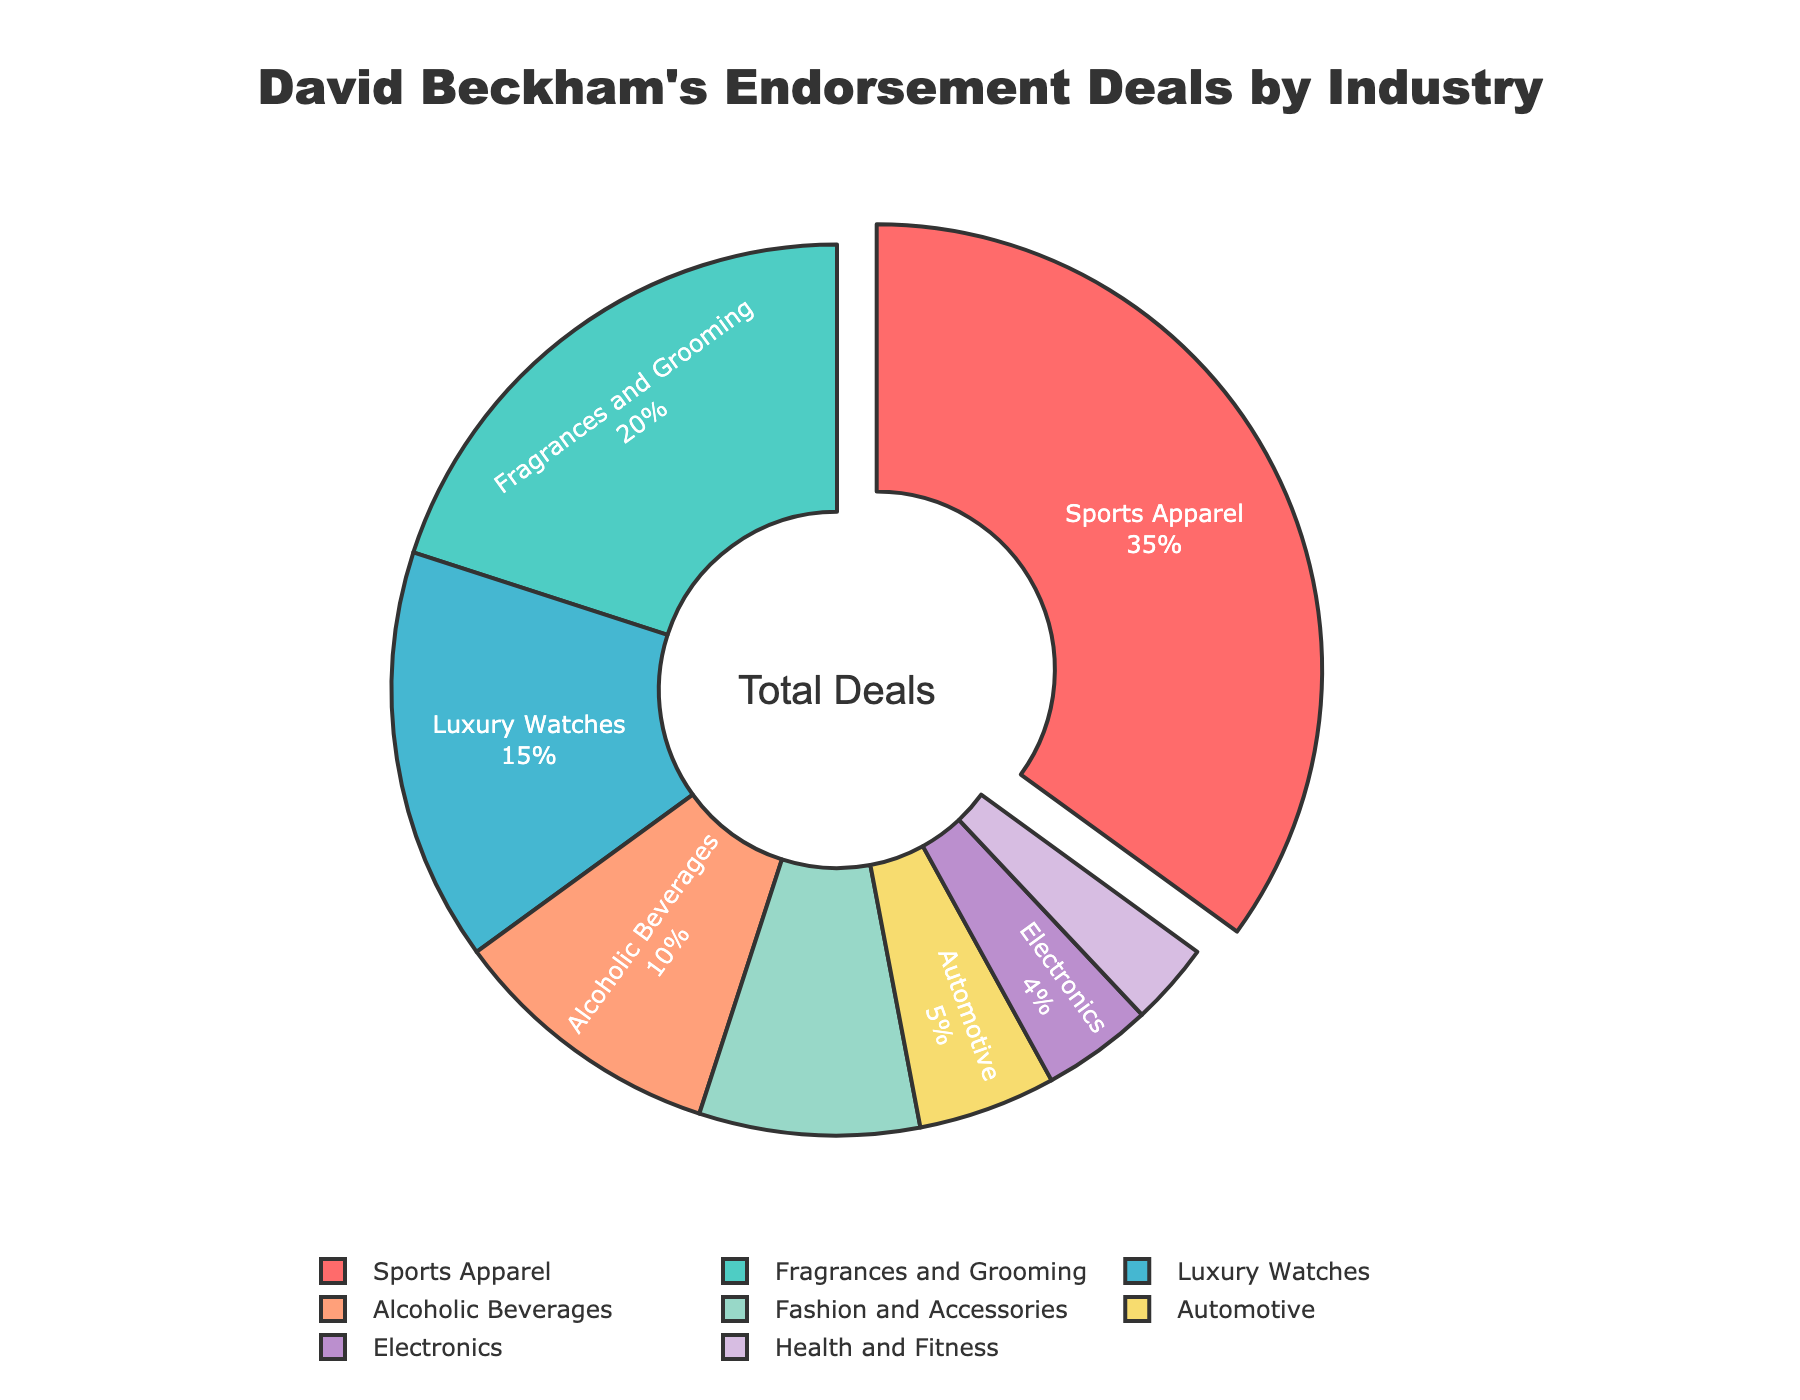What percentage of David Beckham's endorsement deals are in the Sports Apparel sector? The Sports Apparel sector occupies 35% of the overall chart, which represents the percentage of endorsement deals in this sector.
Answer: 35% Which sector has the smallest percentage, and what is it? The Health and Fitness sector has the smallest slice in the pie chart, representing 3% of the endorsement deals.
Answer: Health and Fitness, 3% How much larger is the percentage for Sports Apparel compared to Fashion and Accessories? The percentage for Sports Apparel is 35%, and for Fashion and Accessories, it is 8%. The difference is 35% - 8% = 27%.
Answer: 27% What is the combined percentage of endorsement deals in the Luxury Watches and Automotive sectors? The Luxury Watches sector is 15%, and the Automotive sector is 5%. Combined, they account for 15% + 5% = 20%.
Answer: 20% Which sector has a higher percentage of endorsement deals: Alcoholic Beverages or Electronics? The Alcoholic Beverages sector has 10%, whereas the Electronics sector has 4%. Alcoholic Beverages have a higher percentage.
Answer: Alcoholic Beverages What percentage of endorsement deals are in sectors other than Sports Apparel, Fragrances and Grooming, and Luxury Watches? The percentages for Sports Apparel, Fragrances and Grooming, and Luxury Watches are 35%, 20%, and 15%, respectively. The other sectors collectively account for 100% - (35% + 20% + 15%) = 30%.
Answer: 30% Rank the sectors by the percentage of endorsement deals from highest to lowest. The sectors ranked from highest to lowest percentage are: Sports Apparel (35%), Fragrances and Grooming (20%), Luxury Watches (15%), Alcoholic Beverages (10%), Fashion and Accessories (8%), Automotive (5%), Electronics (4%), Health and Fitness (3%).
Answer: Sports Apparel, Fragrances and Grooming, Luxury Watches, Alcoholic Beverages, Fashion and Accessories, Automotive, Electronics, Health and Fitness If the sectors with a percentage below 5% combined to form a new category, what would be the new sector's percentage? The sectors with percentages below 5% are Automotive (5%), Electronics (4%), and Health and Fitness (3%). Combining them would result in 5% + 4% + 3% = 12%.
Answer: 12% What is the ratio of the percentage of endorsement deals in Sports Apparel to those in Health and Fitness? The percentage for Sports Apparel is 35%, and for Health and Fitness, it is 3%. The ratio is 35:3, which simplifies to approximately 11.67:1.
Answer: ~11.67:1 